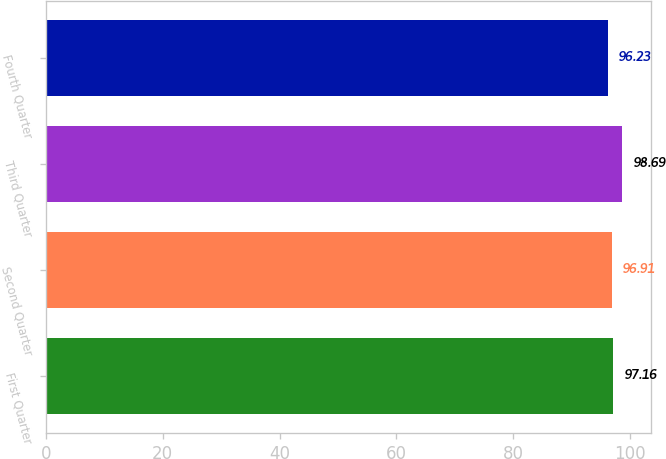Convert chart. <chart><loc_0><loc_0><loc_500><loc_500><bar_chart><fcel>First Quarter<fcel>Second Quarter<fcel>Third Quarter<fcel>Fourth Quarter<nl><fcel>97.16<fcel>96.91<fcel>98.69<fcel>96.23<nl></chart> 